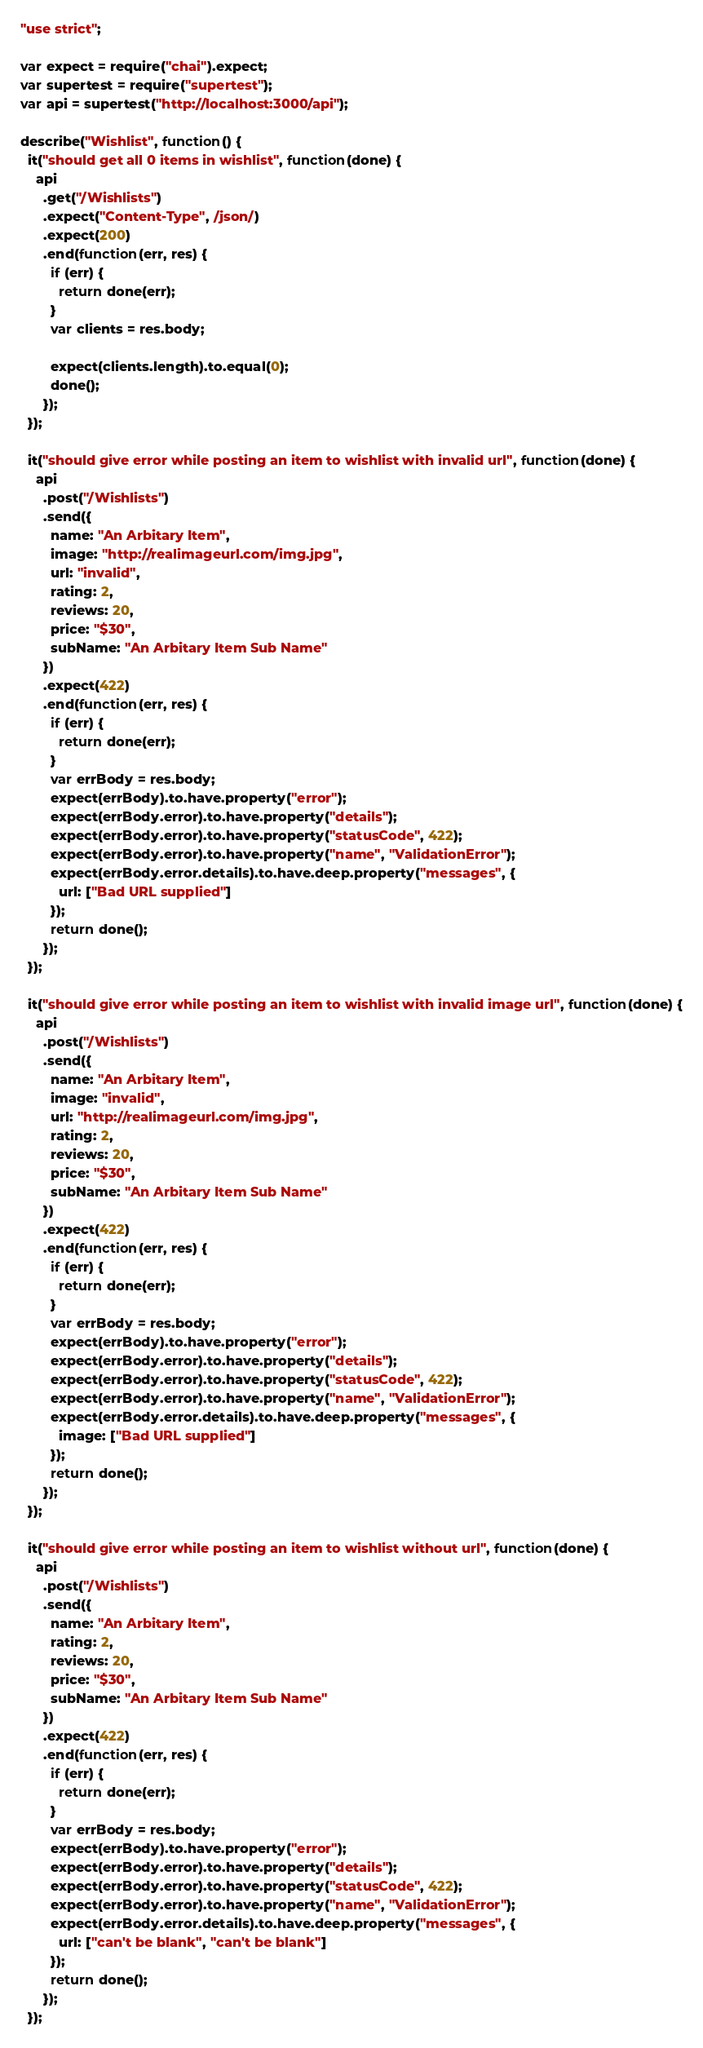Convert code to text. <code><loc_0><loc_0><loc_500><loc_500><_JavaScript_>"use strict";

var expect = require("chai").expect;
var supertest = require("supertest");
var api = supertest("http://localhost:3000/api");

describe("Wishlist", function() {
  it("should get all 0 items in wishlist", function(done) {
    api
      .get("/Wishlists")
      .expect("Content-Type", /json/)
      .expect(200)
      .end(function(err, res) {
        if (err) {
          return done(err);
        }
        var clients = res.body;

        expect(clients.length).to.equal(0);
        done();
      });
  });

  it("should give error while posting an item to wishlist with invalid url", function(done) {
    api
      .post("/Wishlists")
      .send({
        name: "An Arbitary Item",
        image: "http://realimageurl.com/img.jpg",
        url: "invalid",
        rating: 2,
        reviews: 20,
        price: "$30",
        subName: "An Arbitary Item Sub Name"
      })
      .expect(422)
      .end(function(err, res) {
        if (err) {
          return done(err);
        }
        var errBody = res.body;
        expect(errBody).to.have.property("error");
        expect(errBody.error).to.have.property("details");
        expect(errBody.error).to.have.property("statusCode", 422);
        expect(errBody.error).to.have.property("name", "ValidationError");
        expect(errBody.error.details).to.have.deep.property("messages", {
          url: ["Bad URL supplied"]
        });
        return done();
      });
  });

  it("should give error while posting an item to wishlist with invalid image url", function(done) {
    api
      .post("/Wishlists")
      .send({
        name: "An Arbitary Item",
        image: "invalid",
        url: "http://realimageurl.com/img.jpg",
        rating: 2,
        reviews: 20,
        price: "$30",
        subName: "An Arbitary Item Sub Name"
      })
      .expect(422)
      .end(function(err, res) {
        if (err) {
          return done(err);
        }
        var errBody = res.body;
        expect(errBody).to.have.property("error");
        expect(errBody.error).to.have.property("details");
        expect(errBody.error).to.have.property("statusCode", 422);
        expect(errBody.error).to.have.property("name", "ValidationError");
        expect(errBody.error.details).to.have.deep.property("messages", {
          image: ["Bad URL supplied"]
        });
        return done();
      });
  });

  it("should give error while posting an item to wishlist without url", function(done) {
    api
      .post("/Wishlists")
      .send({
        name: "An Arbitary Item",
        rating: 2,
        reviews: 20,
        price: "$30",
        subName: "An Arbitary Item Sub Name"
      })
      .expect(422)
      .end(function(err, res) {
        if (err) {
          return done(err);
        }
        var errBody = res.body;
        expect(errBody).to.have.property("error");
        expect(errBody.error).to.have.property("details");
        expect(errBody.error).to.have.property("statusCode", 422);
        expect(errBody.error).to.have.property("name", "ValidationError");
        expect(errBody.error.details).to.have.deep.property("messages", {
          url: ["can't be blank", "can't be blank"]
        });
        return done();
      });
  });
</code> 